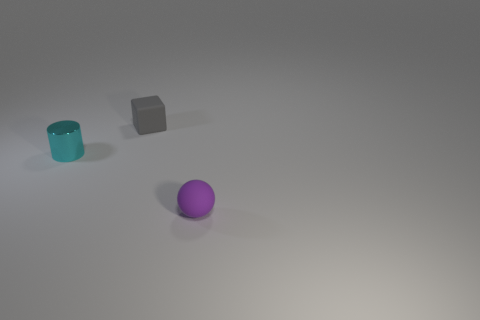Add 3 tiny cyan cubes. How many objects exist? 6 Subtract all balls. How many objects are left? 2 Subtract all gray spheres. Subtract all small gray cubes. How many objects are left? 2 Add 1 small blocks. How many small blocks are left? 2 Add 3 small purple rubber balls. How many small purple rubber balls exist? 4 Subtract 0 yellow balls. How many objects are left? 3 